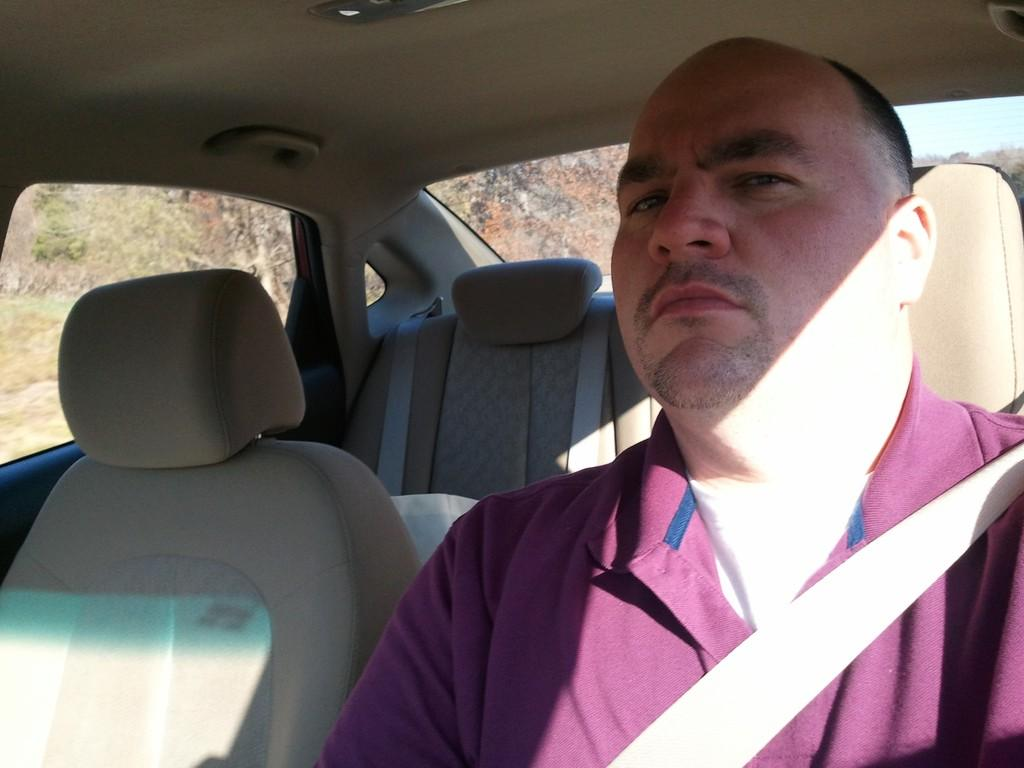What is the person in the image doing? The person is sitting in a car. Is the person taking any safety precautions while sitting in the car? Yes, the person is wearing a seat belt. What can be seen through the car windows? Plants and trees are visible through the car windows. What type of cake is being served to the group of people in the image? There is no group of people or cake present in the image; it features a person sitting in a car. 